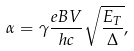Convert formula to latex. <formula><loc_0><loc_0><loc_500><loc_500>\alpha = \gamma \frac { e B V } { h c } \sqrt { \frac { E _ { T } } { \Delta } } ,</formula> 